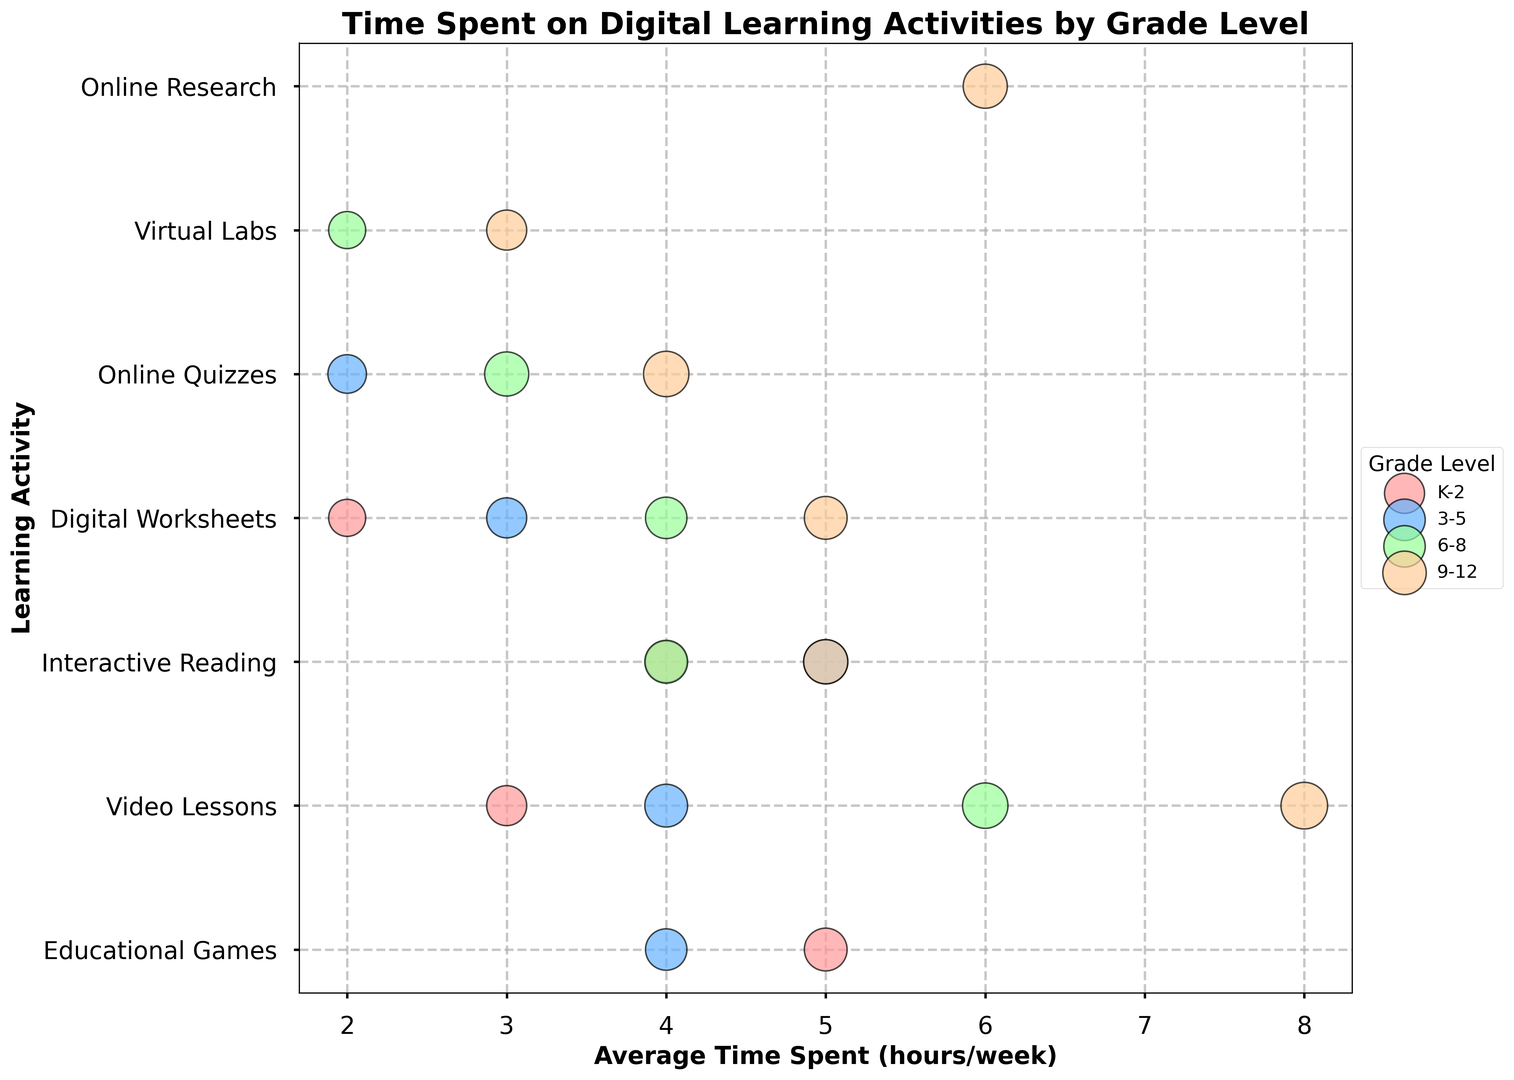Which grade level spends the most average time on Video Lessons? To determine this, look for the bubble representing Video Lessons and check the average time spent for each grade level. The 9-12 grade level spends 8 hours on Video Lessons, which is the highest.
Answer: 9-12 Which two learning activities have the highest average time spent in the grade level 6-8? Focus on the bubbles corresponding to 6-8 grade level and compare the average time spent on each learning activity. Video Lessons and Interactive Reading both stand out.
Answer: Video Lessons, Interactive Reading What is the average percentage of students using Digital Worksheets across all grades? Calculate the average by adding the percentages of students using Digital Worksheets for each grade level and then dividing by the number of grade levels: (60 + 70 + 75 + 80) / 4 = 71.25%.
Answer: 71.25% Which grade level has the widest variety of learning activities recorded? Count the different learning activities for each grade level. Grade level 9-12 has 5 learning activities, which is the most variety.
Answer: 9-12 Comparing Educational Games and Virtual Labs, which learning activity has a higher engagement in grade level 3-5? Look at the percentage of students for Educational Games and Virtual Labs in grade level 3-5. Educational Games has a higher percentage (75%) compared to Virtual Labs (not applicable for 3-5).
Answer: Educational Games Which learning activity is unique to grades 6-8 and 9-12 but not present in lower grades (K-5)? Identify the learning activities present only in grades 6-8 and 9-12 and exclude those in K-5. Virtual Labs and Online Research are unique to 6-8 and 9-12.
Answer: Virtual Labs, Online Research What is the difference in the average time spent on Interactive Reading between grades 3-5 and grades 9-12? Find the average time spent on Interactive Reading for both grade levels and subtract the lower from the higher: 5 hours (9-12) - 5 hours (3-5) = 0 hours.
Answer: 0 hours Which grade level has the highest engagement in Online Quizzes and by what percentage? Check the percentage of students for Online Quizzes across all grade levels. In grade 9-12, 90% of students engage in Online Quizzes, which is the highest.
Answer: 9-12, 90% Among the grade levels, which has the most visually prominent (largest) bubble for Educational Games? Visually, the size of the bubble is proportional to the percentage of students. Grade K-2 has the largest bubble for Educational Games.
Answer: K-2 